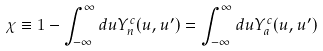Convert formula to latex. <formula><loc_0><loc_0><loc_500><loc_500>\chi \equiv 1 - \int _ { - \infty } ^ { \infty } d u Y _ { n } ^ { c } ( u , u ^ { \prime } ) = \int _ { - \infty } ^ { \infty } d u Y _ { a } ^ { c } ( u , u ^ { \prime } )</formula> 